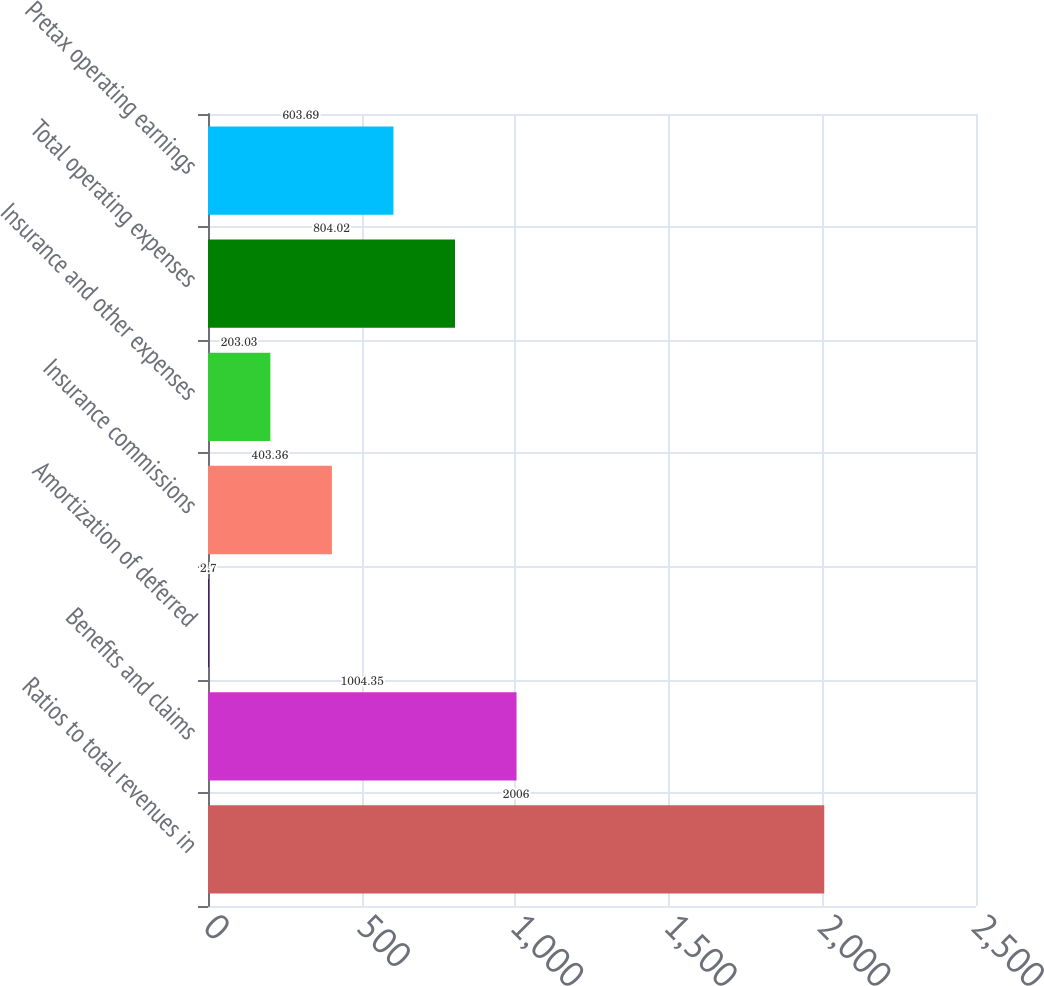<chart> <loc_0><loc_0><loc_500><loc_500><bar_chart><fcel>Ratios to total revenues in<fcel>Benefits and claims<fcel>Amortization of deferred<fcel>Insurance commissions<fcel>Insurance and other expenses<fcel>Total operating expenses<fcel>Pretax operating earnings<nl><fcel>2006<fcel>1004.35<fcel>2.7<fcel>403.36<fcel>203.03<fcel>804.02<fcel>603.69<nl></chart> 